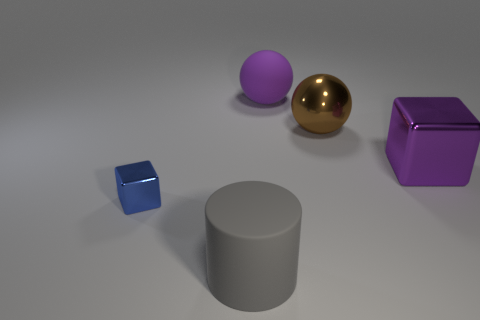Add 5 blue blocks. How many objects exist? 10 Subtract all blocks. How many objects are left? 3 Add 4 big brown metallic balls. How many big brown metallic balls are left? 5 Add 2 green rubber cylinders. How many green rubber cylinders exist? 2 Subtract 1 purple spheres. How many objects are left? 4 Subtract all yellow shiny things. Subtract all brown metal balls. How many objects are left? 4 